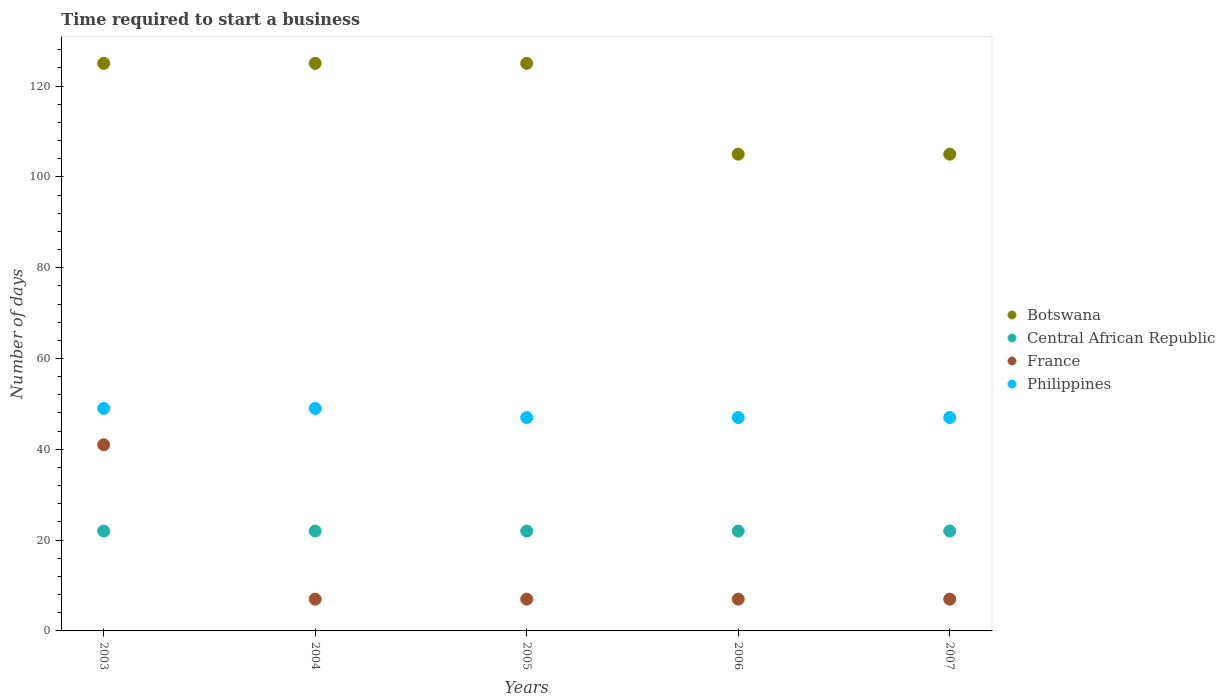Is the number of dotlines equal to the number of legend labels?
Your response must be concise. Yes. What is the number of days required to start a business in Botswana in 2005?
Your answer should be very brief. 125. Across all years, what is the maximum number of days required to start a business in Botswana?
Offer a very short reply. 125. Across all years, what is the minimum number of days required to start a business in France?
Make the answer very short. 7. In which year was the number of days required to start a business in Botswana maximum?
Offer a very short reply. 2003. In which year was the number of days required to start a business in Philippines minimum?
Provide a succinct answer. 2005. What is the difference between the number of days required to start a business in Philippines in 2004 and that in 2005?
Offer a very short reply. 2. What is the difference between the number of days required to start a business in Botswana in 2006 and the number of days required to start a business in Philippines in 2007?
Give a very brief answer. 58. What is the average number of days required to start a business in France per year?
Offer a very short reply. 13.8. In the year 2005, what is the difference between the number of days required to start a business in Botswana and number of days required to start a business in Philippines?
Your answer should be very brief. 78. What is the ratio of the number of days required to start a business in France in 2004 to that in 2007?
Provide a succinct answer. 1. What is the difference between the highest and the lowest number of days required to start a business in Botswana?
Your response must be concise. 20. In how many years, is the number of days required to start a business in Botswana greater than the average number of days required to start a business in Botswana taken over all years?
Offer a terse response. 3. Is it the case that in every year, the sum of the number of days required to start a business in Botswana and number of days required to start a business in Philippines  is greater than the sum of number of days required to start a business in Central African Republic and number of days required to start a business in France?
Your answer should be very brief. Yes. Does the number of days required to start a business in Botswana monotonically increase over the years?
Ensure brevity in your answer.  No. Is the number of days required to start a business in Botswana strictly greater than the number of days required to start a business in France over the years?
Offer a terse response. Yes. How many dotlines are there?
Your answer should be compact. 4. How many years are there in the graph?
Keep it short and to the point. 5. Does the graph contain any zero values?
Keep it short and to the point. No. Does the graph contain grids?
Offer a terse response. No. Where does the legend appear in the graph?
Offer a very short reply. Center right. How many legend labels are there?
Provide a succinct answer. 4. How are the legend labels stacked?
Offer a terse response. Vertical. What is the title of the graph?
Provide a short and direct response. Time required to start a business. Does "Kenya" appear as one of the legend labels in the graph?
Ensure brevity in your answer.  No. What is the label or title of the X-axis?
Your answer should be compact. Years. What is the label or title of the Y-axis?
Provide a succinct answer. Number of days. What is the Number of days of Botswana in 2003?
Your response must be concise. 125. What is the Number of days in Central African Republic in 2003?
Offer a very short reply. 22. What is the Number of days of France in 2003?
Provide a succinct answer. 41. What is the Number of days of Botswana in 2004?
Ensure brevity in your answer.  125. What is the Number of days in Central African Republic in 2004?
Your response must be concise. 22. What is the Number of days in Botswana in 2005?
Provide a succinct answer. 125. What is the Number of days of Central African Republic in 2005?
Keep it short and to the point. 22. What is the Number of days in France in 2005?
Your answer should be compact. 7. What is the Number of days of Philippines in 2005?
Your answer should be very brief. 47. What is the Number of days of Botswana in 2006?
Offer a terse response. 105. What is the Number of days in Central African Republic in 2006?
Your answer should be very brief. 22. What is the Number of days in France in 2006?
Offer a very short reply. 7. What is the Number of days of Philippines in 2006?
Your answer should be very brief. 47. What is the Number of days of Botswana in 2007?
Offer a very short reply. 105. What is the Number of days of Philippines in 2007?
Offer a very short reply. 47. Across all years, what is the maximum Number of days of Botswana?
Your answer should be very brief. 125. Across all years, what is the maximum Number of days of Central African Republic?
Ensure brevity in your answer.  22. Across all years, what is the maximum Number of days in France?
Keep it short and to the point. 41. Across all years, what is the maximum Number of days of Philippines?
Offer a very short reply. 49. Across all years, what is the minimum Number of days in Botswana?
Your answer should be very brief. 105. Across all years, what is the minimum Number of days in Central African Republic?
Make the answer very short. 22. Across all years, what is the minimum Number of days in France?
Your answer should be very brief. 7. What is the total Number of days of Botswana in the graph?
Your response must be concise. 585. What is the total Number of days in Central African Republic in the graph?
Offer a terse response. 110. What is the total Number of days of France in the graph?
Provide a short and direct response. 69. What is the total Number of days in Philippines in the graph?
Your answer should be compact. 239. What is the difference between the Number of days in Philippines in 2003 and that in 2004?
Your answer should be very brief. 0. What is the difference between the Number of days in Botswana in 2003 and that in 2005?
Your answer should be very brief. 0. What is the difference between the Number of days in Central African Republic in 2003 and that in 2005?
Make the answer very short. 0. What is the difference between the Number of days of France in 2003 and that in 2006?
Offer a very short reply. 34. What is the difference between the Number of days in Philippines in 2003 and that in 2006?
Ensure brevity in your answer.  2. What is the difference between the Number of days in Botswana in 2003 and that in 2007?
Ensure brevity in your answer.  20. What is the difference between the Number of days in Central African Republic in 2004 and that in 2005?
Your response must be concise. 0. What is the difference between the Number of days of France in 2004 and that in 2005?
Keep it short and to the point. 0. What is the difference between the Number of days in Botswana in 2004 and that in 2006?
Your answer should be very brief. 20. What is the difference between the Number of days in Central African Republic in 2004 and that in 2006?
Offer a very short reply. 0. What is the difference between the Number of days in France in 2004 and that in 2006?
Your answer should be compact. 0. What is the difference between the Number of days of Central African Republic in 2004 and that in 2007?
Your answer should be very brief. 0. What is the difference between the Number of days in France in 2004 and that in 2007?
Ensure brevity in your answer.  0. What is the difference between the Number of days in Philippines in 2004 and that in 2007?
Keep it short and to the point. 2. What is the difference between the Number of days of Central African Republic in 2005 and that in 2006?
Keep it short and to the point. 0. What is the difference between the Number of days of Botswana in 2005 and that in 2007?
Offer a very short reply. 20. What is the difference between the Number of days in Central African Republic in 2005 and that in 2007?
Provide a succinct answer. 0. What is the difference between the Number of days in France in 2005 and that in 2007?
Give a very brief answer. 0. What is the difference between the Number of days of Philippines in 2005 and that in 2007?
Keep it short and to the point. 0. What is the difference between the Number of days in Botswana in 2006 and that in 2007?
Keep it short and to the point. 0. What is the difference between the Number of days of Central African Republic in 2006 and that in 2007?
Your answer should be very brief. 0. What is the difference between the Number of days in Philippines in 2006 and that in 2007?
Give a very brief answer. 0. What is the difference between the Number of days in Botswana in 2003 and the Number of days in Central African Republic in 2004?
Offer a terse response. 103. What is the difference between the Number of days in Botswana in 2003 and the Number of days in France in 2004?
Give a very brief answer. 118. What is the difference between the Number of days in Botswana in 2003 and the Number of days in Philippines in 2004?
Keep it short and to the point. 76. What is the difference between the Number of days in Botswana in 2003 and the Number of days in Central African Republic in 2005?
Provide a succinct answer. 103. What is the difference between the Number of days of Botswana in 2003 and the Number of days of France in 2005?
Provide a short and direct response. 118. What is the difference between the Number of days in Central African Republic in 2003 and the Number of days in Philippines in 2005?
Offer a terse response. -25. What is the difference between the Number of days in Botswana in 2003 and the Number of days in Central African Republic in 2006?
Your response must be concise. 103. What is the difference between the Number of days in Botswana in 2003 and the Number of days in France in 2006?
Offer a terse response. 118. What is the difference between the Number of days in Central African Republic in 2003 and the Number of days in France in 2006?
Give a very brief answer. 15. What is the difference between the Number of days in Botswana in 2003 and the Number of days in Central African Republic in 2007?
Offer a very short reply. 103. What is the difference between the Number of days in Botswana in 2003 and the Number of days in France in 2007?
Your answer should be very brief. 118. What is the difference between the Number of days of Botswana in 2003 and the Number of days of Philippines in 2007?
Offer a very short reply. 78. What is the difference between the Number of days of France in 2003 and the Number of days of Philippines in 2007?
Offer a terse response. -6. What is the difference between the Number of days of Botswana in 2004 and the Number of days of Central African Republic in 2005?
Give a very brief answer. 103. What is the difference between the Number of days of Botswana in 2004 and the Number of days of France in 2005?
Offer a terse response. 118. What is the difference between the Number of days in Central African Republic in 2004 and the Number of days in France in 2005?
Your answer should be very brief. 15. What is the difference between the Number of days in Central African Republic in 2004 and the Number of days in Philippines in 2005?
Keep it short and to the point. -25. What is the difference between the Number of days in Botswana in 2004 and the Number of days in Central African Republic in 2006?
Give a very brief answer. 103. What is the difference between the Number of days in Botswana in 2004 and the Number of days in France in 2006?
Give a very brief answer. 118. What is the difference between the Number of days in France in 2004 and the Number of days in Philippines in 2006?
Offer a very short reply. -40. What is the difference between the Number of days of Botswana in 2004 and the Number of days of Central African Republic in 2007?
Your response must be concise. 103. What is the difference between the Number of days of Botswana in 2004 and the Number of days of France in 2007?
Keep it short and to the point. 118. What is the difference between the Number of days in Central African Republic in 2004 and the Number of days in France in 2007?
Keep it short and to the point. 15. What is the difference between the Number of days in Central African Republic in 2004 and the Number of days in Philippines in 2007?
Ensure brevity in your answer.  -25. What is the difference between the Number of days of Botswana in 2005 and the Number of days of Central African Republic in 2006?
Your answer should be compact. 103. What is the difference between the Number of days in Botswana in 2005 and the Number of days in France in 2006?
Ensure brevity in your answer.  118. What is the difference between the Number of days of Central African Republic in 2005 and the Number of days of France in 2006?
Ensure brevity in your answer.  15. What is the difference between the Number of days of Botswana in 2005 and the Number of days of Central African Republic in 2007?
Your answer should be compact. 103. What is the difference between the Number of days of Botswana in 2005 and the Number of days of France in 2007?
Give a very brief answer. 118. What is the difference between the Number of days in France in 2005 and the Number of days in Philippines in 2007?
Provide a short and direct response. -40. What is the difference between the Number of days in Botswana in 2006 and the Number of days in Central African Republic in 2007?
Ensure brevity in your answer.  83. What is the difference between the Number of days of Botswana in 2006 and the Number of days of France in 2007?
Keep it short and to the point. 98. What is the difference between the Number of days of Botswana in 2006 and the Number of days of Philippines in 2007?
Make the answer very short. 58. What is the difference between the Number of days in Central African Republic in 2006 and the Number of days in France in 2007?
Offer a terse response. 15. What is the average Number of days of Botswana per year?
Keep it short and to the point. 117. What is the average Number of days of France per year?
Provide a succinct answer. 13.8. What is the average Number of days of Philippines per year?
Make the answer very short. 47.8. In the year 2003, what is the difference between the Number of days in Botswana and Number of days in Central African Republic?
Offer a terse response. 103. In the year 2003, what is the difference between the Number of days in Botswana and Number of days in France?
Give a very brief answer. 84. In the year 2003, what is the difference between the Number of days in France and Number of days in Philippines?
Give a very brief answer. -8. In the year 2004, what is the difference between the Number of days in Botswana and Number of days in Central African Republic?
Provide a short and direct response. 103. In the year 2004, what is the difference between the Number of days of Botswana and Number of days of France?
Your response must be concise. 118. In the year 2004, what is the difference between the Number of days of Central African Republic and Number of days of Philippines?
Offer a very short reply. -27. In the year 2004, what is the difference between the Number of days in France and Number of days in Philippines?
Your response must be concise. -42. In the year 2005, what is the difference between the Number of days in Botswana and Number of days in Central African Republic?
Ensure brevity in your answer.  103. In the year 2005, what is the difference between the Number of days of Botswana and Number of days of France?
Keep it short and to the point. 118. In the year 2006, what is the difference between the Number of days of Botswana and Number of days of Central African Republic?
Offer a very short reply. 83. In the year 2006, what is the difference between the Number of days of Botswana and Number of days of Philippines?
Your answer should be compact. 58. In the year 2006, what is the difference between the Number of days of Central African Republic and Number of days of France?
Offer a terse response. 15. In the year 2006, what is the difference between the Number of days in France and Number of days in Philippines?
Make the answer very short. -40. In the year 2007, what is the difference between the Number of days of Botswana and Number of days of France?
Provide a short and direct response. 98. In the year 2007, what is the difference between the Number of days of Central African Republic and Number of days of France?
Your answer should be compact. 15. In the year 2007, what is the difference between the Number of days in Central African Republic and Number of days in Philippines?
Provide a short and direct response. -25. In the year 2007, what is the difference between the Number of days of France and Number of days of Philippines?
Offer a terse response. -40. What is the ratio of the Number of days in Botswana in 2003 to that in 2004?
Your answer should be very brief. 1. What is the ratio of the Number of days of Central African Republic in 2003 to that in 2004?
Keep it short and to the point. 1. What is the ratio of the Number of days in France in 2003 to that in 2004?
Your answer should be compact. 5.86. What is the ratio of the Number of days in Central African Republic in 2003 to that in 2005?
Ensure brevity in your answer.  1. What is the ratio of the Number of days of France in 2003 to that in 2005?
Offer a very short reply. 5.86. What is the ratio of the Number of days of Philippines in 2003 to that in 2005?
Offer a very short reply. 1.04. What is the ratio of the Number of days in Botswana in 2003 to that in 2006?
Your answer should be very brief. 1.19. What is the ratio of the Number of days of France in 2003 to that in 2006?
Your response must be concise. 5.86. What is the ratio of the Number of days in Philippines in 2003 to that in 2006?
Ensure brevity in your answer.  1.04. What is the ratio of the Number of days in Botswana in 2003 to that in 2007?
Offer a terse response. 1.19. What is the ratio of the Number of days of Central African Republic in 2003 to that in 2007?
Your response must be concise. 1. What is the ratio of the Number of days of France in 2003 to that in 2007?
Your answer should be very brief. 5.86. What is the ratio of the Number of days in Philippines in 2003 to that in 2007?
Provide a short and direct response. 1.04. What is the ratio of the Number of days of Botswana in 2004 to that in 2005?
Offer a terse response. 1. What is the ratio of the Number of days of Central African Republic in 2004 to that in 2005?
Provide a short and direct response. 1. What is the ratio of the Number of days of Philippines in 2004 to that in 2005?
Offer a terse response. 1.04. What is the ratio of the Number of days in Botswana in 2004 to that in 2006?
Offer a terse response. 1.19. What is the ratio of the Number of days of Central African Republic in 2004 to that in 2006?
Give a very brief answer. 1. What is the ratio of the Number of days of Philippines in 2004 to that in 2006?
Your answer should be compact. 1.04. What is the ratio of the Number of days of Botswana in 2004 to that in 2007?
Offer a terse response. 1.19. What is the ratio of the Number of days in France in 2004 to that in 2007?
Your answer should be very brief. 1. What is the ratio of the Number of days of Philippines in 2004 to that in 2007?
Your answer should be very brief. 1.04. What is the ratio of the Number of days in Botswana in 2005 to that in 2006?
Your response must be concise. 1.19. What is the ratio of the Number of days in Central African Republic in 2005 to that in 2006?
Offer a very short reply. 1. What is the ratio of the Number of days in Philippines in 2005 to that in 2006?
Provide a short and direct response. 1. What is the ratio of the Number of days in Botswana in 2005 to that in 2007?
Keep it short and to the point. 1.19. What is the ratio of the Number of days of France in 2005 to that in 2007?
Offer a terse response. 1. What is the ratio of the Number of days of Philippines in 2005 to that in 2007?
Offer a very short reply. 1. What is the ratio of the Number of days of Central African Republic in 2006 to that in 2007?
Make the answer very short. 1. What is the ratio of the Number of days of Philippines in 2006 to that in 2007?
Ensure brevity in your answer.  1. What is the difference between the highest and the second highest Number of days of Botswana?
Your answer should be compact. 0. What is the difference between the highest and the second highest Number of days of France?
Keep it short and to the point. 34. What is the difference between the highest and the lowest Number of days of France?
Keep it short and to the point. 34. What is the difference between the highest and the lowest Number of days in Philippines?
Give a very brief answer. 2. 